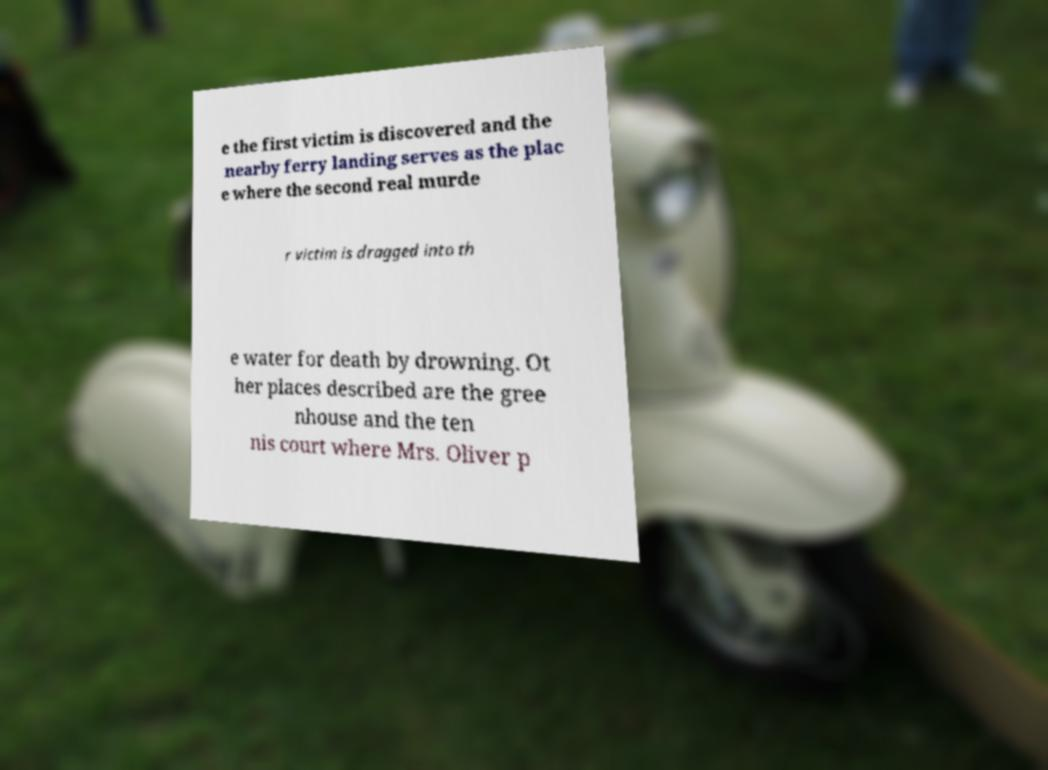What messages or text are displayed in this image? I need them in a readable, typed format. e the first victim is discovered and the nearby ferry landing serves as the plac e where the second real murde r victim is dragged into th e water for death by drowning. Ot her places described are the gree nhouse and the ten nis court where Mrs. Oliver p 